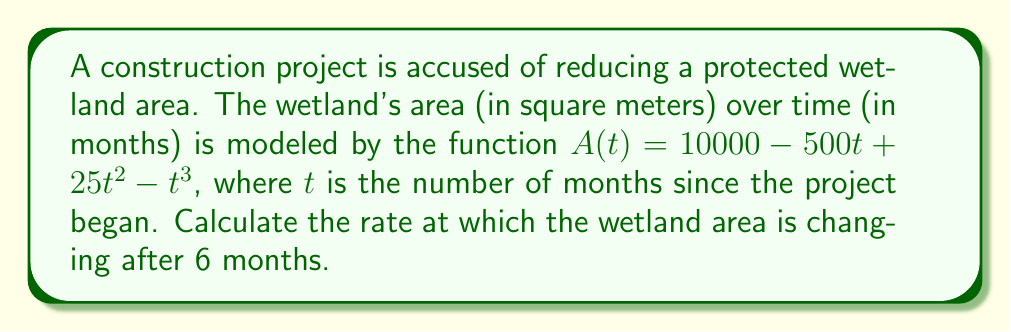Provide a solution to this math problem. To find the rate of change of the wetland area after 6 months, we need to:

1. Find the derivative of $A(t)$ with respect to $t$. This gives us the rate of change function.

2. Evaluate the derivative at $t = 6$.

Step 1: Finding the derivative of $A(t)$

$$\begin{align}
A(t) &= 10000 - 500t + 25t^2 - t^3 \\
A'(t) &= -500 + 50t - 3t^2
\end{align}$$

The derivative $A'(t)$ represents the instantaneous rate of change of the wetland area with respect to time.

Step 2: Evaluating the derivative at $t = 6$

$$\begin{align}
A'(6) &= -500 + 50(6) - 3(6)^2 \\
&= -500 + 300 - 3(36) \\
&= -500 + 300 - 108 \\
&= -308
\end{align}$$

The negative value indicates that the wetland area is decreasing after 6 months.
Answer: $-308$ m²/month 